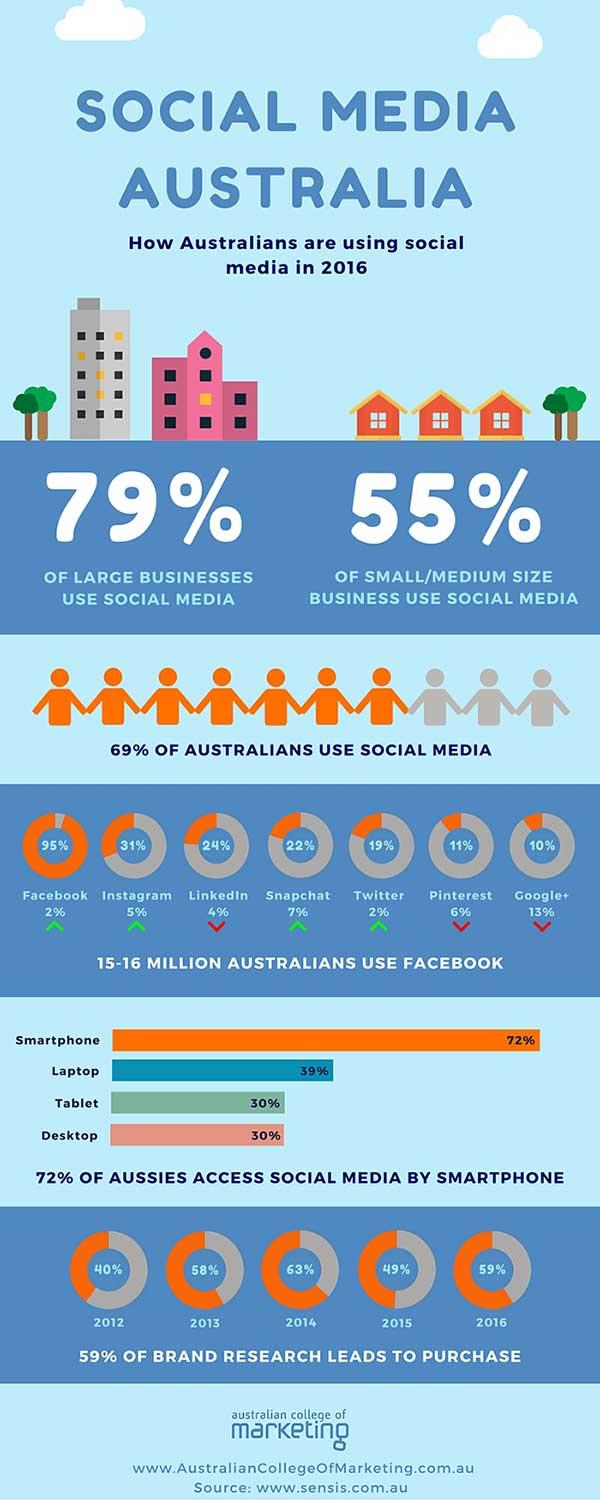Draw attention to some important aspects in this diagram. In 2012, there was the least amount of brand research percentage compared to the other years. In the year 2016, the Australian population that used Facebook numbered approximately 15-16 million people. According to a recent survey, only 21% of large businesses do not use social media. According to a recent survey, 31% of Australians do not use social media. The brand research percentage was highest in 2014. 